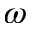Convert formula to latex. <formula><loc_0><loc_0><loc_500><loc_500>\omega</formula> 